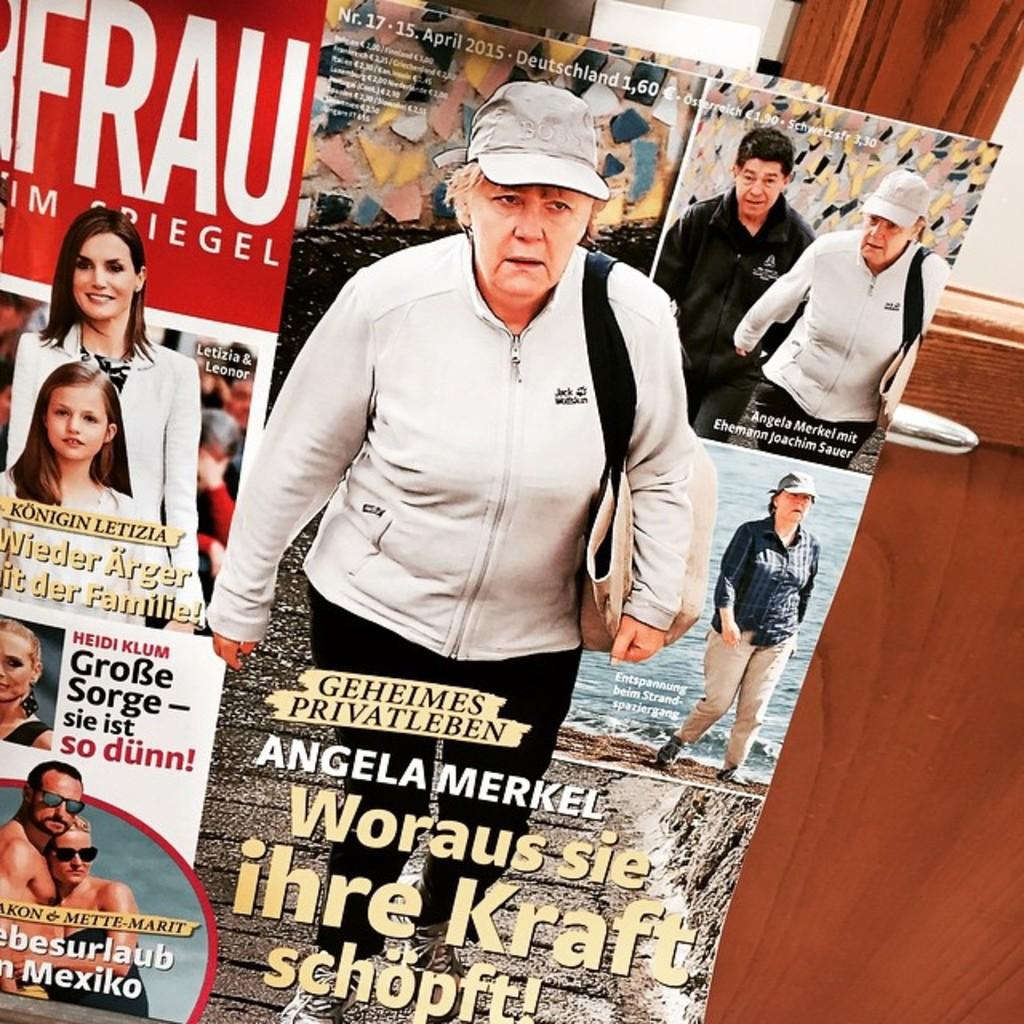What is the main subject of the image? The main subject of the image is a magazine cover page. What can be seen on the cover page? The cover page features a few persons and has text on it. What is located at the right side of the image? There is a wooden door at the right side of the image. How many apples are being held by the persons on the magazine cover page? There are no apples visible on the magazine cover page in the image. What type of clover is growing near the wooden door? There is no clover present in the image; it only features a magazine cover page and a wooden door. 